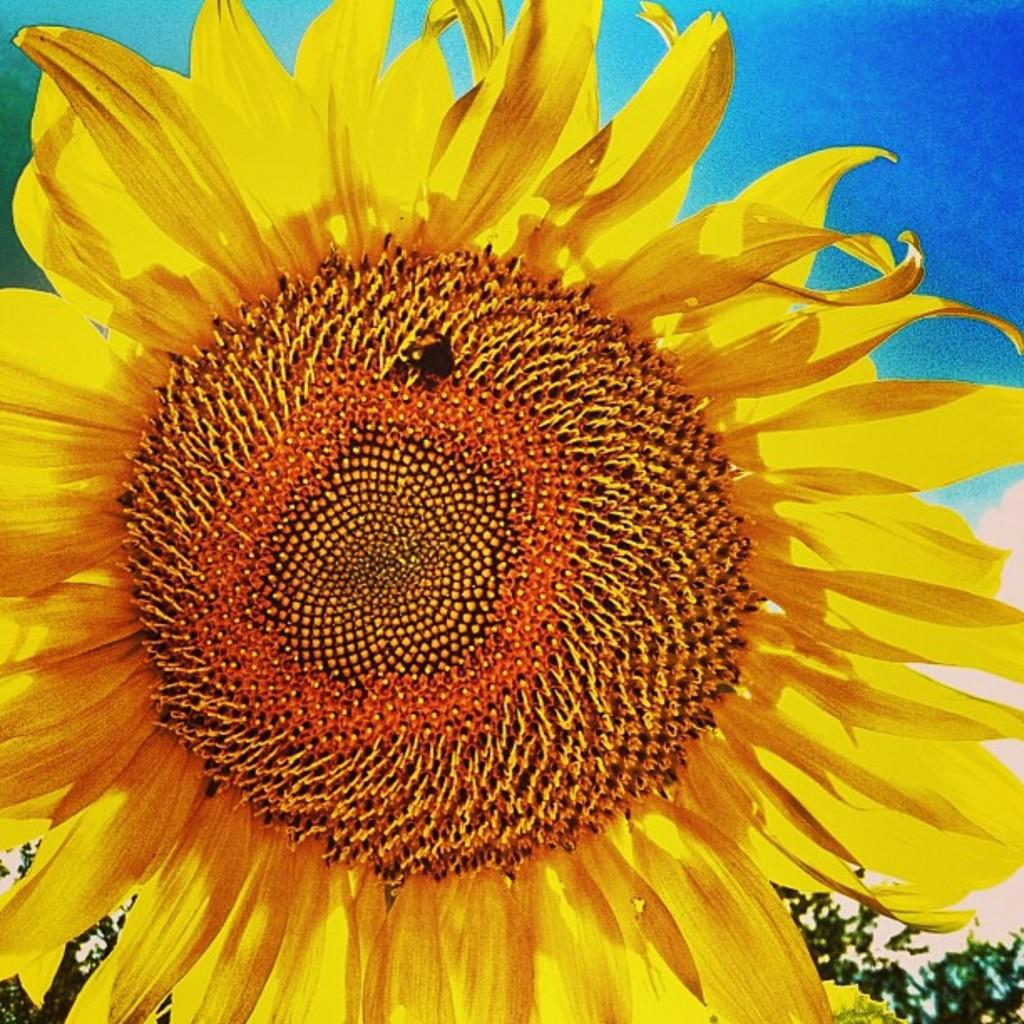What type of plant is in the image? There is a sunflower in the image. What color is the sky in the background of the image? The sky is blue in the background of the image. Where is the frog sitting on the sunflower in the image? There is no frog present in the image; it only features a sunflower. What type of pickle is being used to hold the sunflower in the image? There is no pickle present in the image; the sunflower is not being held by any object. 